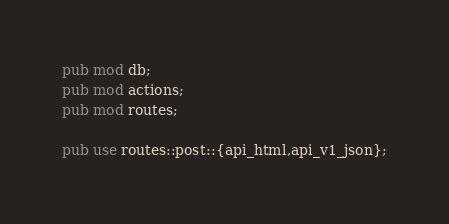Convert code to text. <code><loc_0><loc_0><loc_500><loc_500><_Rust_>pub mod db;
pub mod actions;
pub mod routes;

pub use routes::post::{api_html,api_v1_json};
</code> 